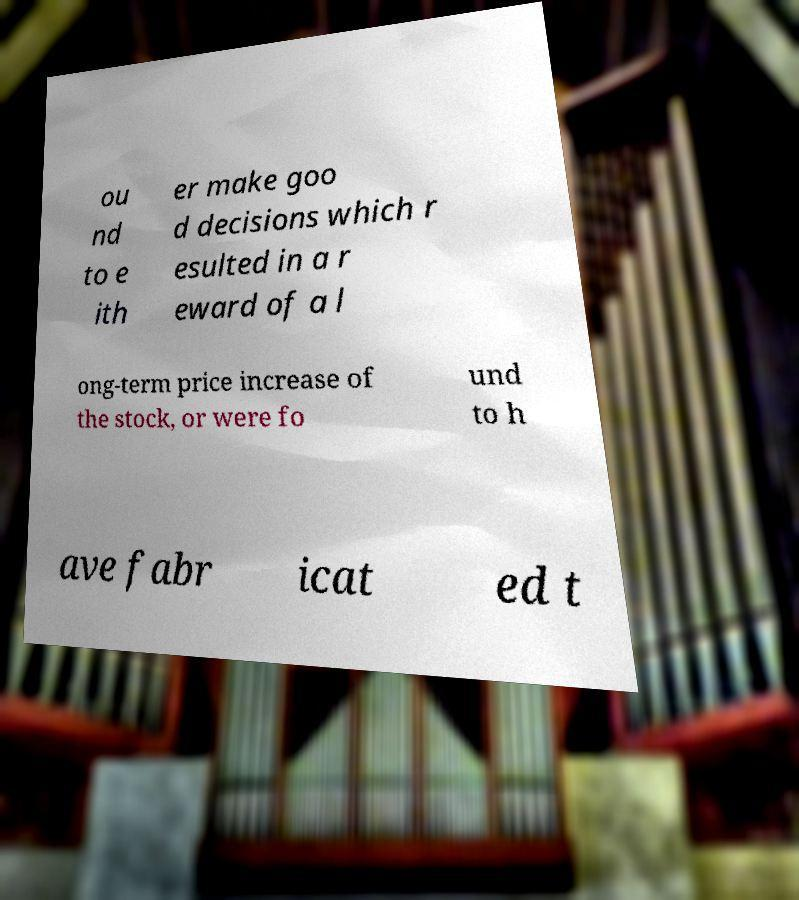There's text embedded in this image that I need extracted. Can you transcribe it verbatim? ou nd to e ith er make goo d decisions which r esulted in a r eward of a l ong-term price increase of the stock, or were fo und to h ave fabr icat ed t 